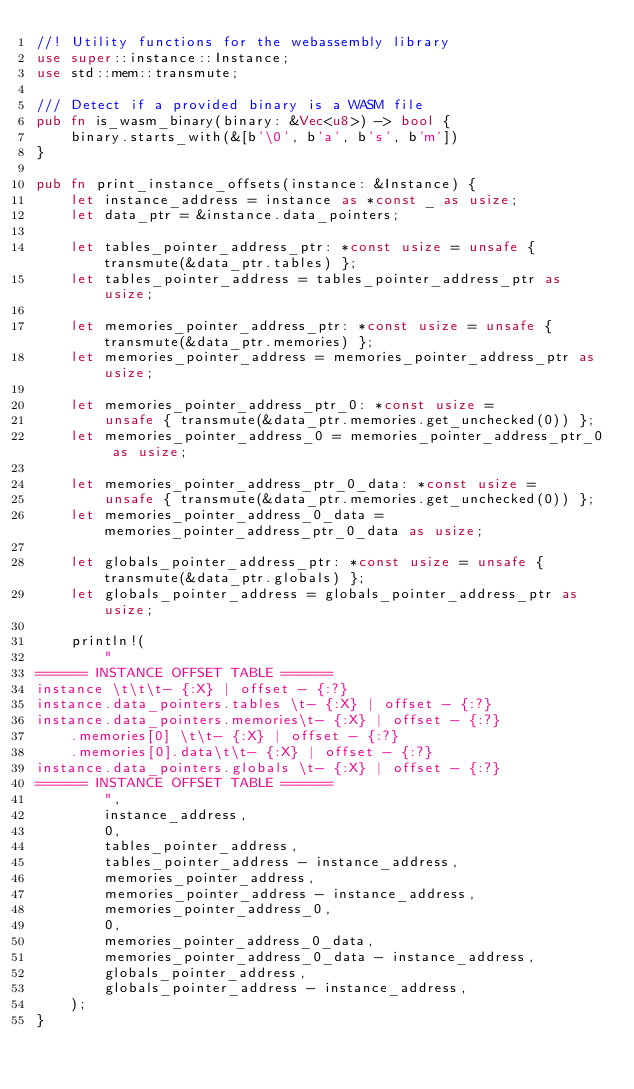Convert code to text. <code><loc_0><loc_0><loc_500><loc_500><_Rust_>//! Utility functions for the webassembly library
use super::instance::Instance;
use std::mem::transmute;

/// Detect if a provided binary is a WASM file
pub fn is_wasm_binary(binary: &Vec<u8>) -> bool {
    binary.starts_with(&[b'\0', b'a', b's', b'm'])
}

pub fn print_instance_offsets(instance: &Instance) {
    let instance_address = instance as *const _ as usize;
    let data_ptr = &instance.data_pointers;

    let tables_pointer_address_ptr: *const usize = unsafe { transmute(&data_ptr.tables) };
    let tables_pointer_address = tables_pointer_address_ptr as usize;

    let memories_pointer_address_ptr: *const usize = unsafe { transmute(&data_ptr.memories) };
    let memories_pointer_address = memories_pointer_address_ptr as usize;

    let memories_pointer_address_ptr_0: *const usize =
        unsafe { transmute(&data_ptr.memories.get_unchecked(0)) };
    let memories_pointer_address_0 = memories_pointer_address_ptr_0 as usize;

    let memories_pointer_address_ptr_0_data: *const usize =
        unsafe { transmute(&data_ptr.memories.get_unchecked(0)) };
    let memories_pointer_address_0_data = memories_pointer_address_ptr_0_data as usize;

    let globals_pointer_address_ptr: *const usize = unsafe { transmute(&data_ptr.globals) };
    let globals_pointer_address = globals_pointer_address_ptr as usize;

    println!(
        "
====== INSTANCE OFFSET TABLE ======
instance \t\t\t- {:X} | offset - {:?}
instance.data_pointers.tables \t- {:X} | offset - {:?}
instance.data_pointers.memories\t- {:X} | offset - {:?}
    .memories[0] \t\t- {:X} | offset - {:?}
    .memories[0].data\t\t- {:X} | offset - {:?}
instance.data_pointers.globals \t- {:X} | offset - {:?}
====== INSTANCE OFFSET TABLE ======
        ",
        instance_address,
        0,
        tables_pointer_address,
        tables_pointer_address - instance_address,
        memories_pointer_address,
        memories_pointer_address - instance_address,
        memories_pointer_address_0,
        0,
        memories_pointer_address_0_data,
        memories_pointer_address_0_data - instance_address,
        globals_pointer_address,
        globals_pointer_address - instance_address,
    );
}
</code> 